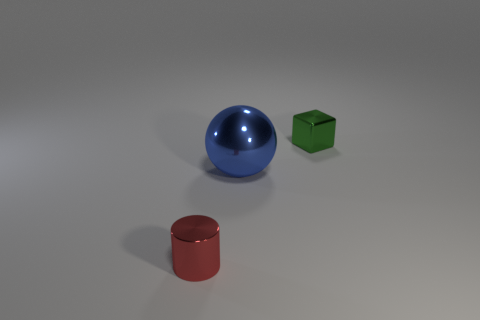There is another large thing that is the same material as the green thing; what shape is it? The object that is the same material as the green cube is a blue sphere. This sphere has a glossy finish and reflects the light, just like the green cube does. 